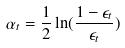Convert formula to latex. <formula><loc_0><loc_0><loc_500><loc_500>\alpha _ { t } = \frac { 1 } { 2 } \ln ( \frac { 1 - \epsilon _ { t } } { \epsilon _ { t } } )</formula> 